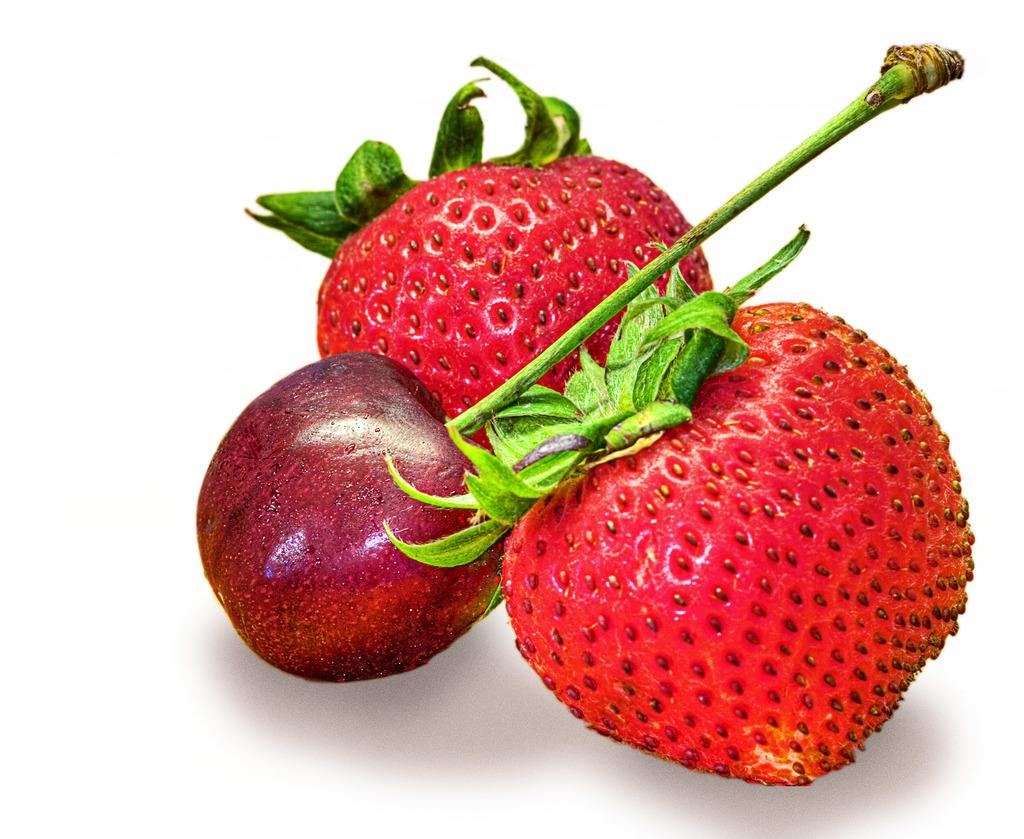What type of fruit can be seen in the image? There are strawberries and a cherry in the image. What is the color of the surface on which the objects are placed? The objects are on a white surface. What type of soda is being poured into the glass in the image? There is no glass or soda present in the image; it only features strawberries and a cherry on a white surface. 